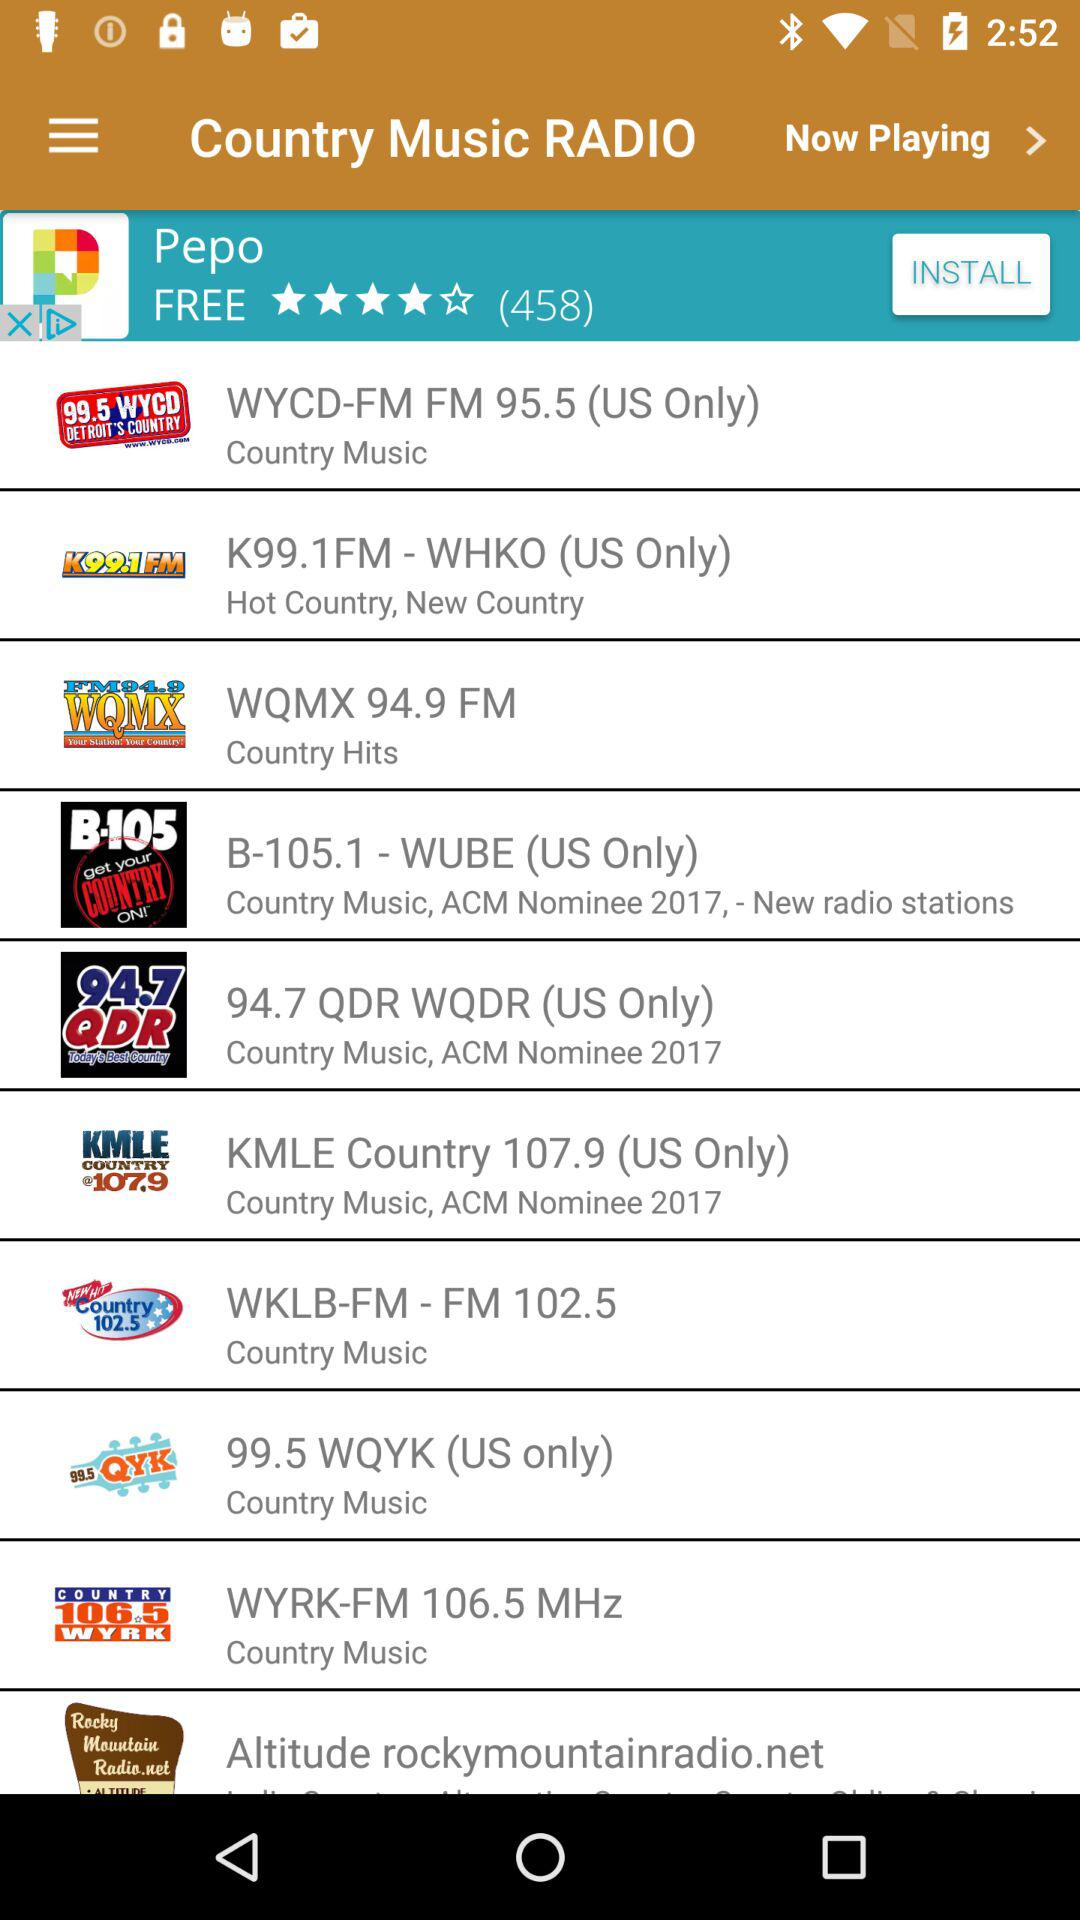What is the application name? The application name is "Country Music RADIO". 